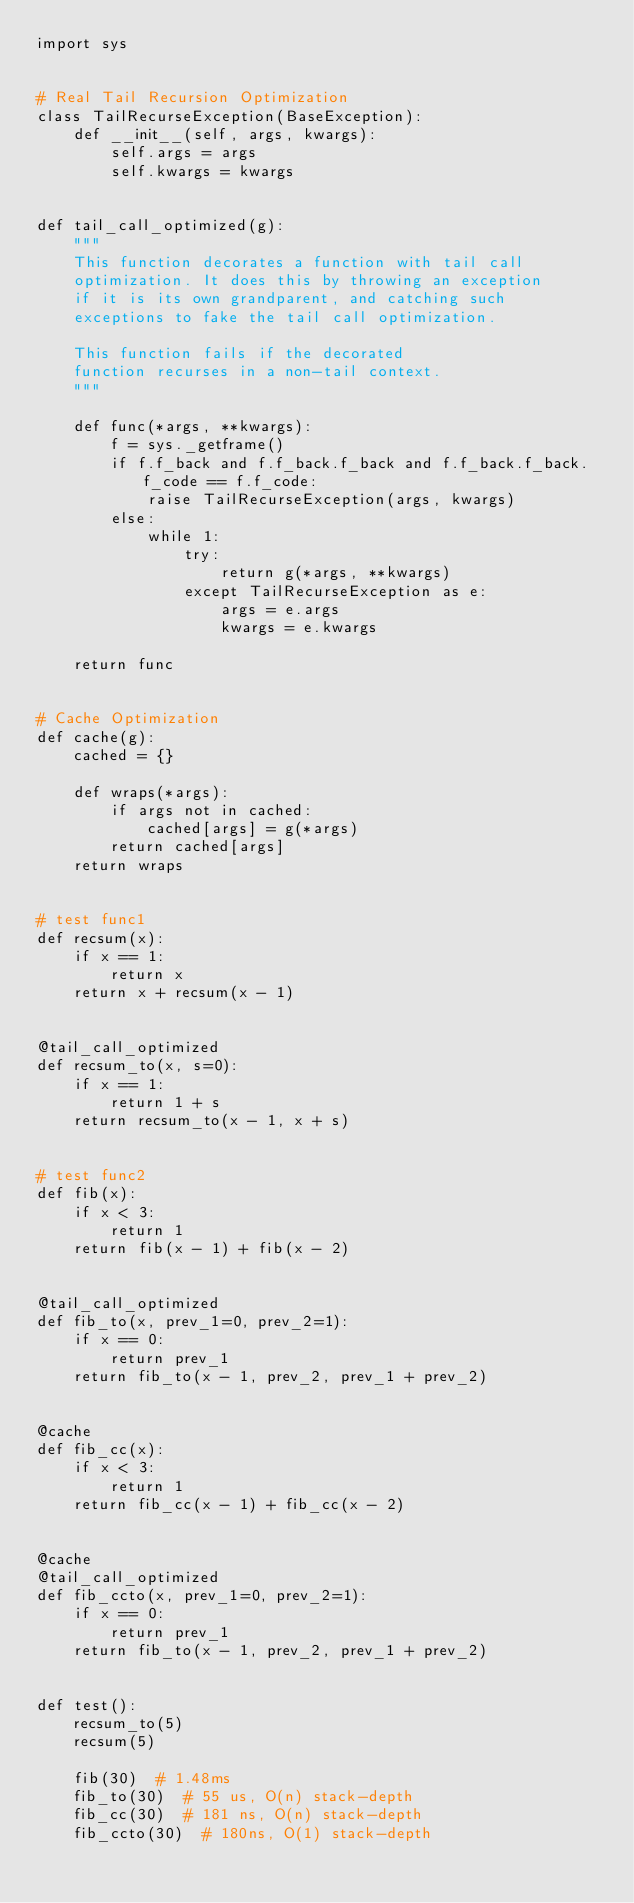<code> <loc_0><loc_0><loc_500><loc_500><_Python_>import sys


# Real Tail Recursion Optimization
class TailRecurseException(BaseException):
    def __init__(self, args, kwargs):
        self.args = args
        self.kwargs = kwargs


def tail_call_optimized(g):
    """
    This function decorates a function with tail call
    optimization. It does this by throwing an exception
    if it is its own grandparent, and catching such
    exceptions to fake the tail call optimization.

    This function fails if the decorated
    function recurses in a non-tail context.
    """

    def func(*args, **kwargs):
        f = sys._getframe()
        if f.f_back and f.f_back.f_back and f.f_back.f_back.f_code == f.f_code:
            raise TailRecurseException(args, kwargs)
        else:
            while 1:
                try:
                    return g(*args, **kwargs)
                except TailRecurseException as e:
                    args = e.args
                    kwargs = e.kwargs

    return func


# Cache Optimization
def cache(g):
    cached = {}

    def wraps(*args):
        if args not in cached:
            cached[args] = g(*args)
        return cached[args]
    return wraps


# test func1
def recsum(x):
    if x == 1:
        return x
    return x + recsum(x - 1)


@tail_call_optimized
def recsum_to(x, s=0):
    if x == 1:
        return 1 + s
    return recsum_to(x - 1, x + s)


# test func2
def fib(x):
    if x < 3:
        return 1
    return fib(x - 1) + fib(x - 2)


@tail_call_optimized
def fib_to(x, prev_1=0, prev_2=1):
    if x == 0:
        return prev_1
    return fib_to(x - 1, prev_2, prev_1 + prev_2)


@cache
def fib_cc(x):
    if x < 3:
        return 1
    return fib_cc(x - 1) + fib_cc(x - 2)


@cache
@tail_call_optimized
def fib_ccto(x, prev_1=0, prev_2=1):
    if x == 0:
        return prev_1
    return fib_to(x - 1, prev_2, prev_1 + prev_2)


def test():
    recsum_to(5)
    recsum(5)

    fib(30)  # 1.48ms
    fib_to(30)  # 55 us, O(n) stack-depth
    fib_cc(30)  # 181 ns, O(n) stack-depth
    fib_ccto(30)  # 180ns, O(1) stack-depth
</code> 